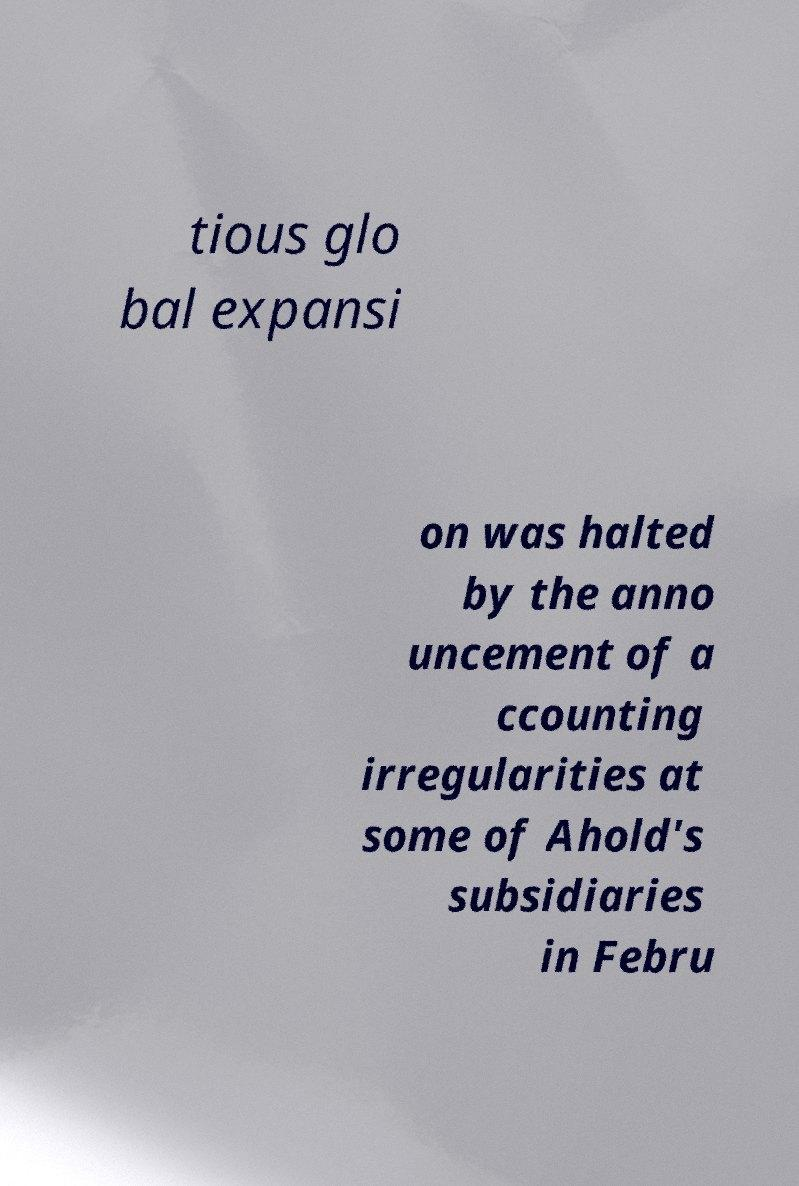Could you extract and type out the text from this image? tious glo bal expansi on was halted by the anno uncement of a ccounting irregularities at some of Ahold's subsidiaries in Febru 